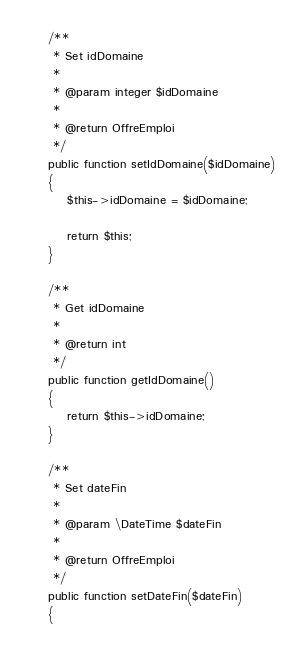Convert code to text. <code><loc_0><loc_0><loc_500><loc_500><_PHP_>
    /**
     * Set idDomaine
     *
     * @param integer $idDomaine
     *
     * @return OffreEmploi
     */
    public function setIdDomaine($idDomaine)
    {
        $this->idDomaine = $idDomaine;

        return $this;
    }

    /**
     * Get idDomaine
     *
     * @return int
     */
    public function getIdDomaine()
    {
        return $this->idDomaine;
    }

    /**
     * Set dateFin
     *
     * @param \DateTime $dateFin
     *
     * @return OffreEmploi
     */
    public function setDateFin($dateFin)
    {</code> 